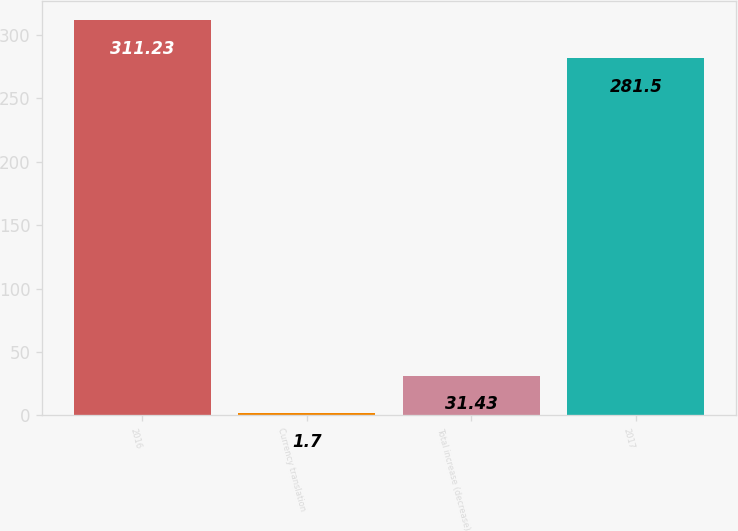<chart> <loc_0><loc_0><loc_500><loc_500><bar_chart><fcel>2016<fcel>Currency translation<fcel>Total increase (decrease)<fcel>2017<nl><fcel>311.23<fcel>1.7<fcel>31.43<fcel>281.5<nl></chart> 